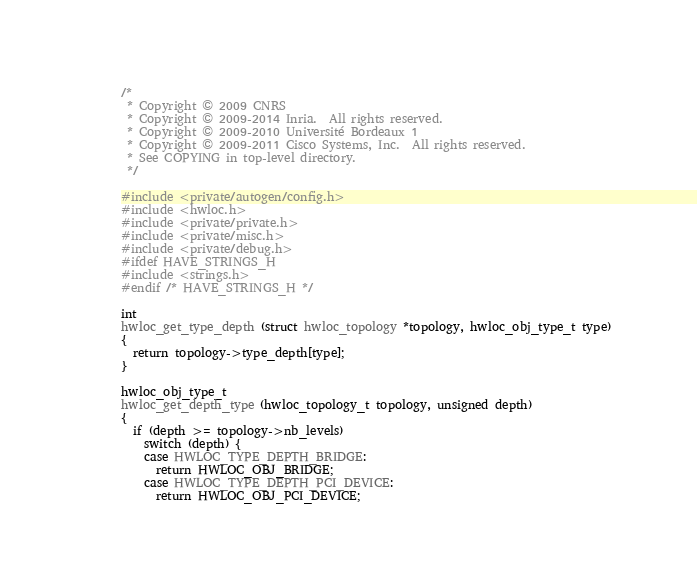Convert code to text. <code><loc_0><loc_0><loc_500><loc_500><_C_>/*
 * Copyright © 2009 CNRS
 * Copyright © 2009-2014 Inria.  All rights reserved.
 * Copyright © 2009-2010 Université Bordeaux 1
 * Copyright © 2009-2011 Cisco Systems, Inc.  All rights reserved.
 * See COPYING in top-level directory.
 */

#include <private/autogen/config.h>
#include <hwloc.h>
#include <private/private.h>
#include <private/misc.h>
#include <private/debug.h>
#ifdef HAVE_STRINGS_H
#include <strings.h>
#endif /* HAVE_STRINGS_H */

int
hwloc_get_type_depth (struct hwloc_topology *topology, hwloc_obj_type_t type)
{
  return topology->type_depth[type];
}

hwloc_obj_type_t
hwloc_get_depth_type (hwloc_topology_t topology, unsigned depth)
{
  if (depth >= topology->nb_levels)
    switch (depth) {
    case HWLOC_TYPE_DEPTH_BRIDGE:
      return HWLOC_OBJ_BRIDGE;
    case HWLOC_TYPE_DEPTH_PCI_DEVICE:
      return HWLOC_OBJ_PCI_DEVICE;</code> 